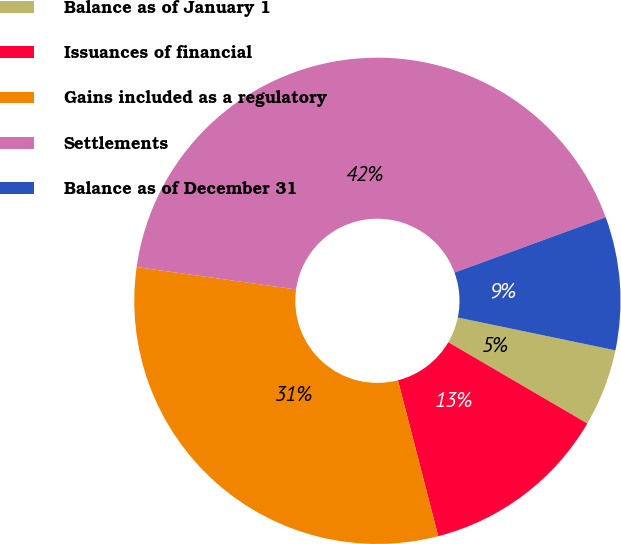Convert chart. <chart><loc_0><loc_0><loc_500><loc_500><pie_chart><fcel>Balance as of January 1<fcel>Issuances of financial<fcel>Gains included as a regulatory<fcel>Settlements<fcel>Balance as of December 31<nl><fcel>5.15%<fcel>12.56%<fcel>31.24%<fcel>42.2%<fcel>8.85%<nl></chart> 